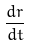Convert formula to latex. <formula><loc_0><loc_0><loc_500><loc_500>\frac { d r } { d t }</formula> 